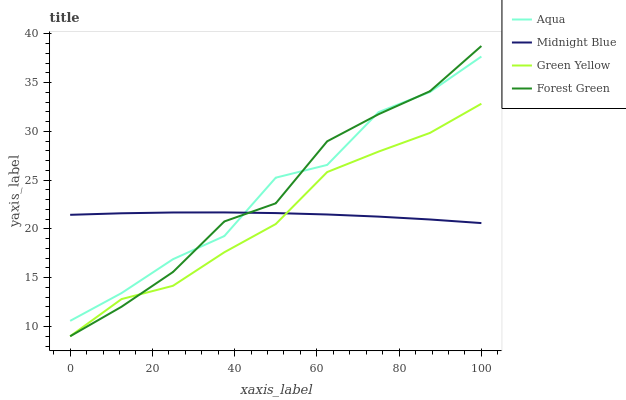Does Aqua have the minimum area under the curve?
Answer yes or no. No. Does Green Yellow have the maximum area under the curve?
Answer yes or no. No. Is Green Yellow the smoothest?
Answer yes or no. No. Is Green Yellow the roughest?
Answer yes or no. No. Does Aqua have the lowest value?
Answer yes or no. No. Does Green Yellow have the highest value?
Answer yes or no. No. Is Green Yellow less than Aqua?
Answer yes or no. Yes. Is Aqua greater than Green Yellow?
Answer yes or no. Yes. Does Green Yellow intersect Aqua?
Answer yes or no. No. 